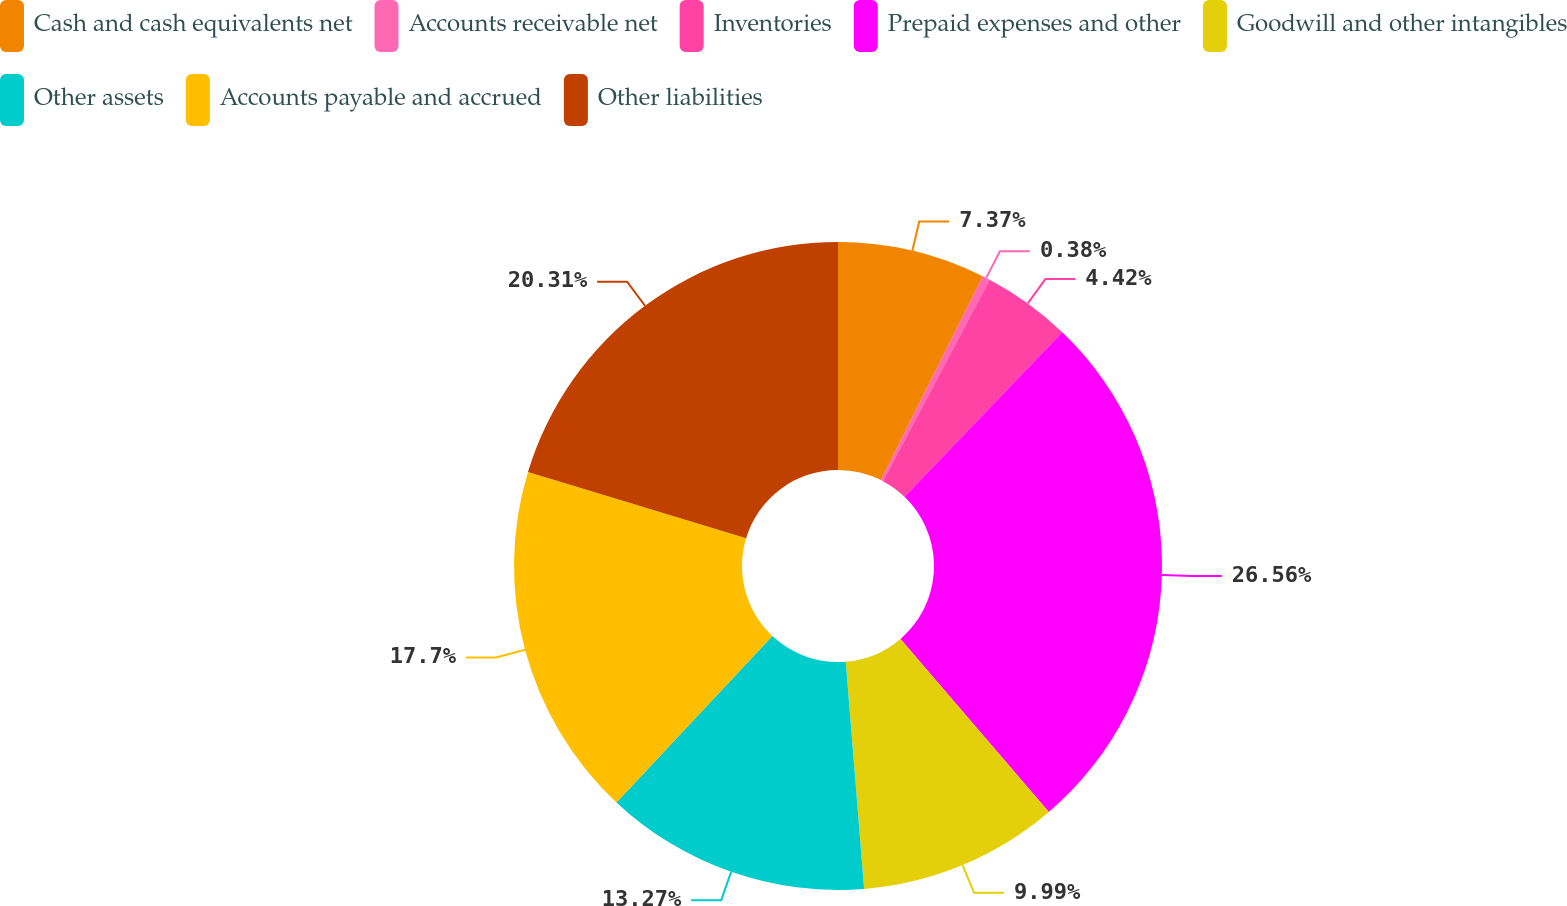<chart> <loc_0><loc_0><loc_500><loc_500><pie_chart><fcel>Cash and cash equivalents net<fcel>Accounts receivable net<fcel>Inventories<fcel>Prepaid expenses and other<fcel>Goodwill and other intangibles<fcel>Other assets<fcel>Accounts payable and accrued<fcel>Other liabilities<nl><fcel>7.37%<fcel>0.38%<fcel>4.42%<fcel>26.55%<fcel>9.99%<fcel>13.27%<fcel>17.7%<fcel>20.31%<nl></chart> 